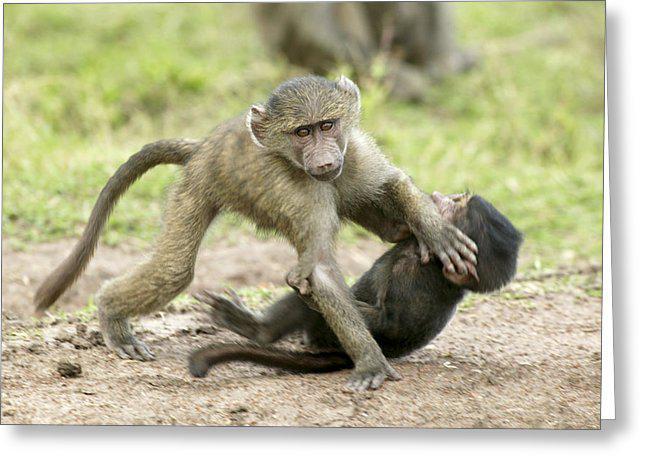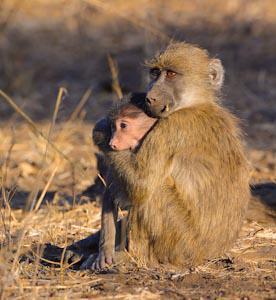The first image is the image on the left, the second image is the image on the right. Considering the images on both sides, is "An image includes a brown monkey with its arms reaching down below its head and its rear higher than its head." valid? Answer yes or no. No. The first image is the image on the left, the second image is the image on the right. Analyze the images presented: Is the assertion "There are exactly four monkeys." valid? Answer yes or no. Yes. 